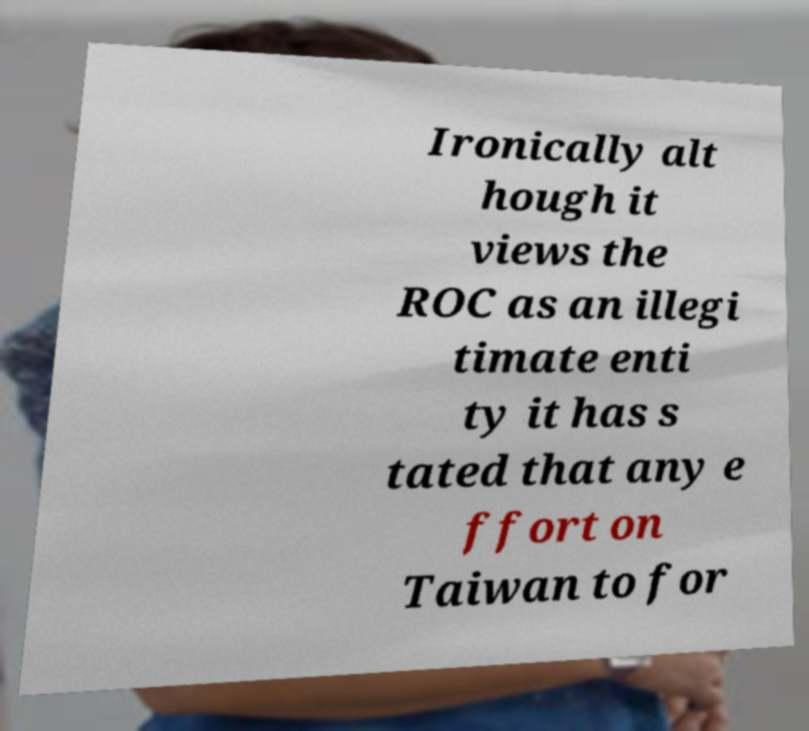For documentation purposes, I need the text within this image transcribed. Could you provide that? Ironically alt hough it views the ROC as an illegi timate enti ty it has s tated that any e ffort on Taiwan to for 